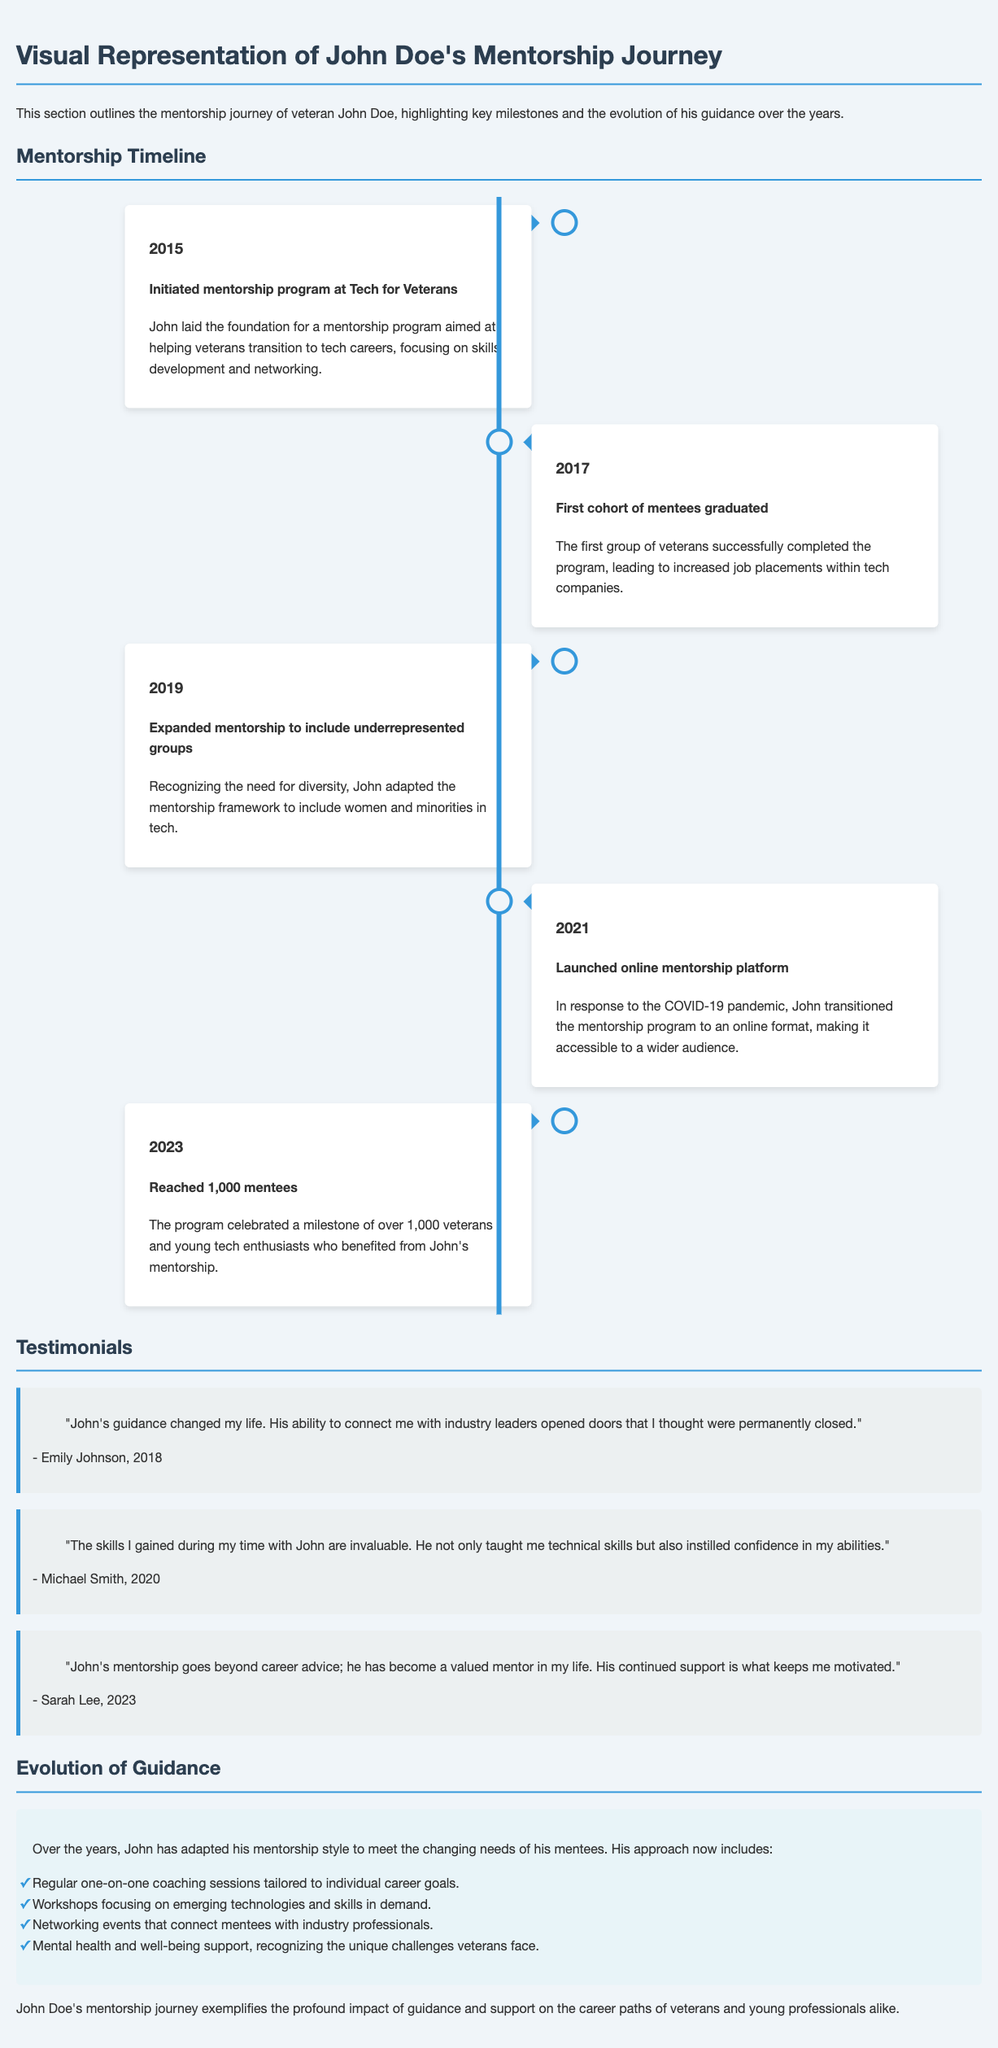What year did John initiate the mentorship program? The document states that John initiated the mentorship program in 2015.
Answer: 2015 How many mentees did the program reach in 2023? According to the document, the program celebrated reaching over 1,000 mentees in 2023.
Answer: 1,000 What did John’s mentorship program adapt to include in 2019? The document mentions that in 2019, John expanded the mentorship framework to include underrepresented groups.
Answer: Underrepresented groups Which cohort graduated in 2017? The document indicates that the first cohort of mentees graduated in 2017.
Answer: First cohort What is one aspect John’s guidance has evolved to include? The document lists that one aspect is regular one-on-one coaching sessions tailored to individual career goals.
Answer: One-on-one coaching sessions What major change was made to the mentorship program in 2021? The document states that in 2021, John launched an online mentorship platform.
Answer: Online mentorship platform Who provided a testimonial in 2023? The document cites Sarah Lee as a mentee who provided a testimonial in 2023.
Answer: Sarah Lee What year did John recognize the need for diversity in his mentorship? The document states that John recognized the need for diversity in 2019.
Answer: 2019 What are the colors used in the design of the document? The document primarily uses blue and gray tones throughout the design.
Answer: Blue and gray 